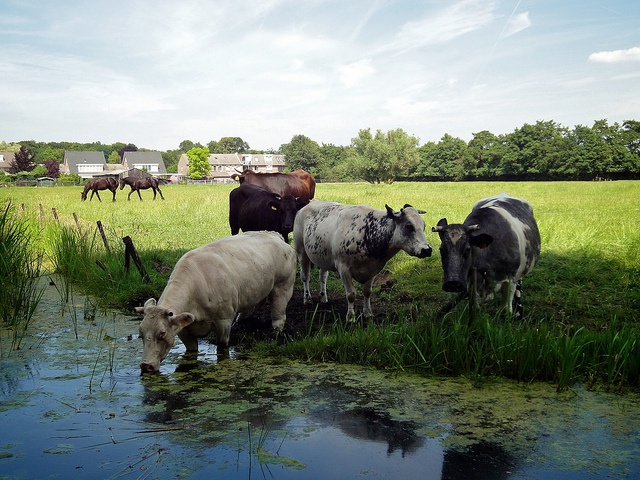Describe the objects in this image and their specific colors. I can see cow in lightblue, gray, black, and darkgray tones, cow in lightblue, black, gray, and darkgray tones, cow in lightblue, black, gray, and darkgray tones, cow in lightblue, black, and gray tones, and cow in lightblue, gray, maroon, and black tones in this image. 